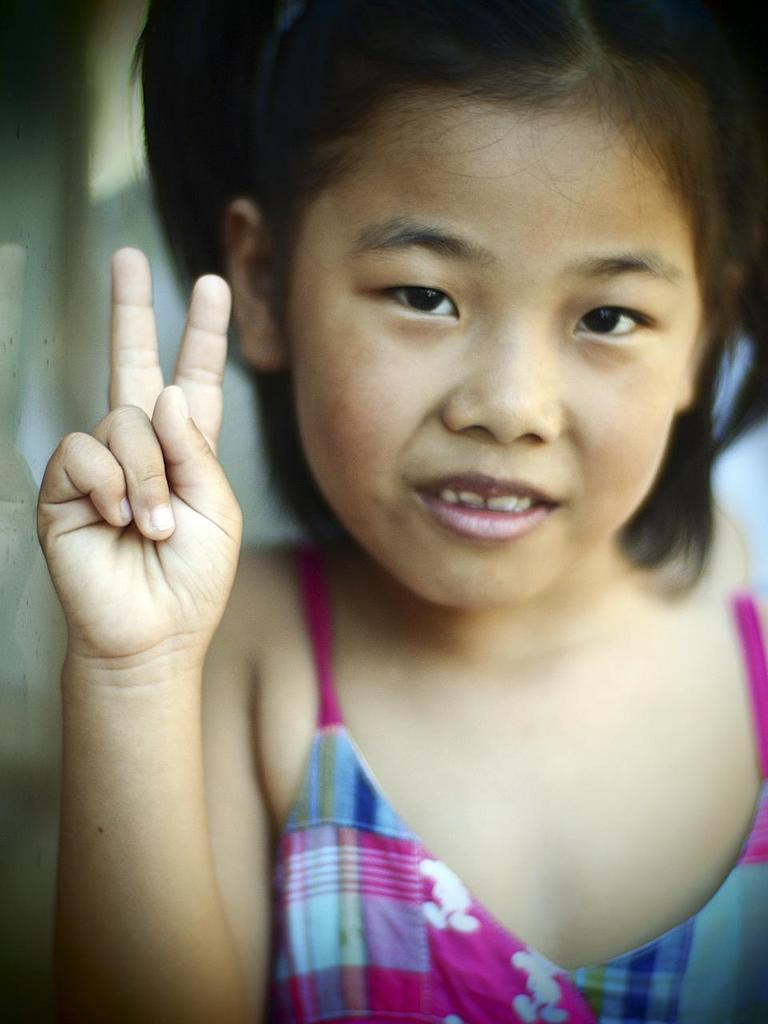Who is the main subject in the image? There is a girl in the image. What is the girl doing in the image? The girl is smiling in the image. Can you describe the background of the image? The background of the image is blurry. How many tomatoes are on the girl's head in the image? There are no tomatoes present in the image. What type of cent is visible in the image? There is no cent present in the image. 